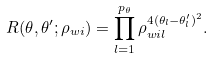Convert formula to latex. <formula><loc_0><loc_0><loc_500><loc_500>R ( \theta , \theta ^ { \prime } ; \rho _ { w i } ) = \prod _ { l = 1 } ^ { p _ { \theta } } \rho _ { w i l } ^ { 4 ( \theta _ { l } - \theta ^ { \prime } _ { l } ) ^ { 2 } } .</formula> 